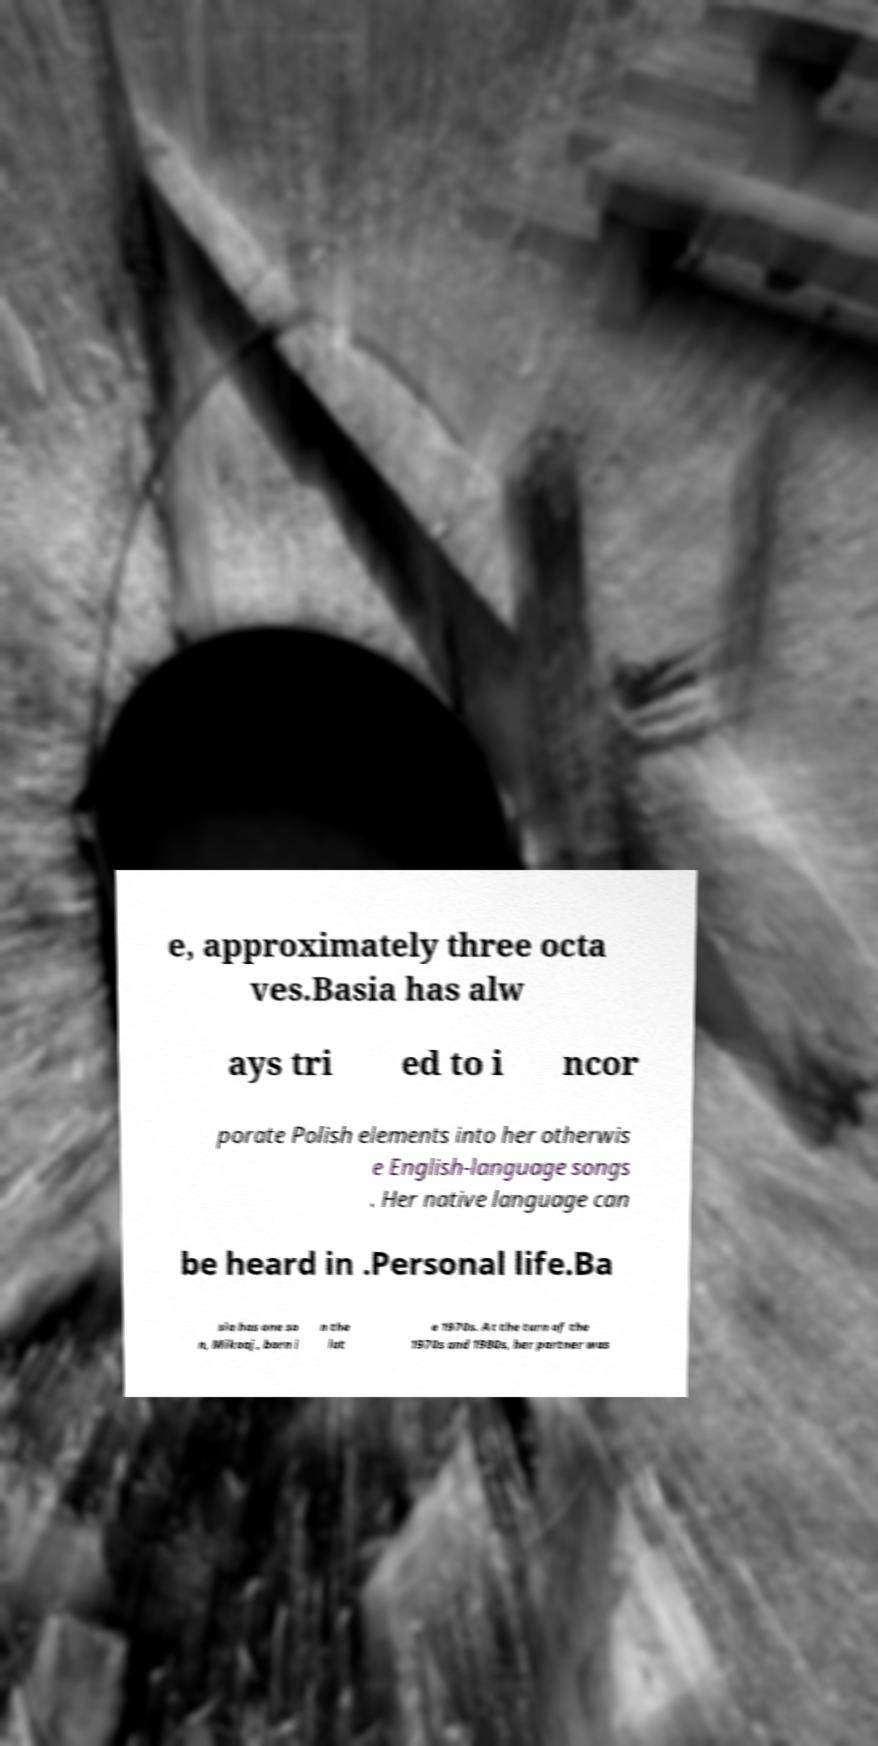Could you assist in decoding the text presented in this image and type it out clearly? e, approximately three octa ves.Basia has alw ays tri ed to i ncor porate Polish elements into her otherwis e English-language songs . Her native language can be heard in .Personal life.Ba sia has one so n, Mikoaj, born i n the lat e 1970s. At the turn of the 1970s and 1980s, her partner was 